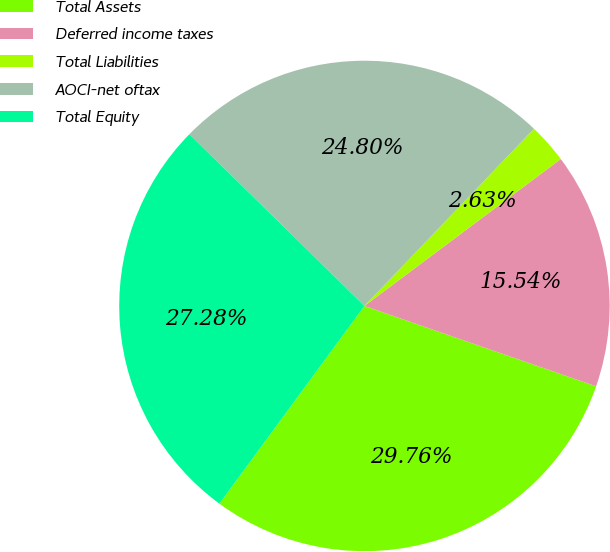Convert chart to OTSL. <chart><loc_0><loc_0><loc_500><loc_500><pie_chart><fcel>Total Assets<fcel>Deferred income taxes<fcel>Total Liabilities<fcel>AOCI-net oftax<fcel>Total Equity<nl><fcel>29.76%<fcel>15.54%<fcel>2.63%<fcel>24.8%<fcel>27.28%<nl></chart> 